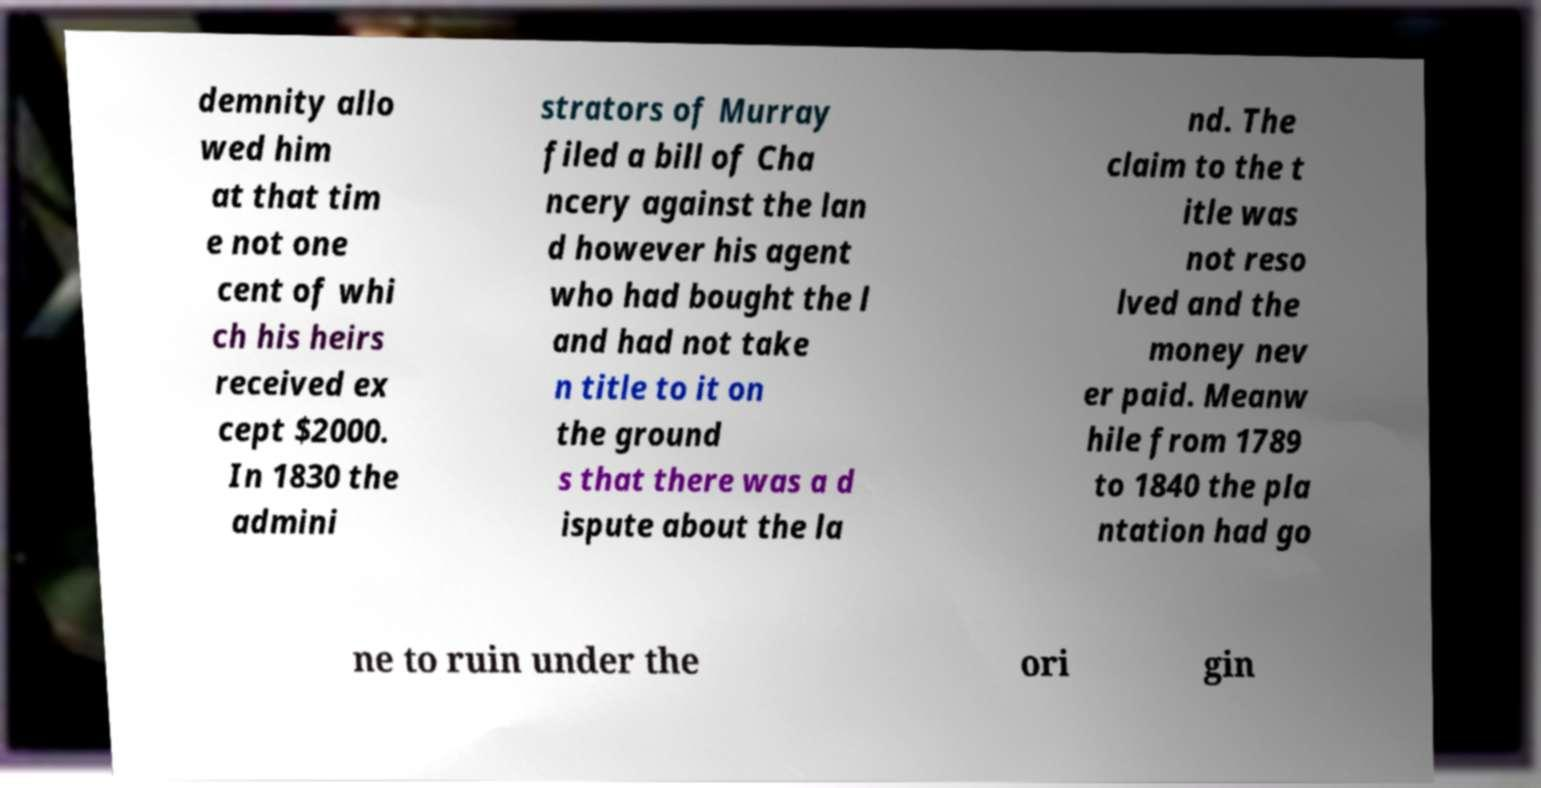I need the written content from this picture converted into text. Can you do that? demnity allo wed him at that tim e not one cent of whi ch his heirs received ex cept $2000. In 1830 the admini strators of Murray filed a bill of Cha ncery against the lan d however his agent who had bought the l and had not take n title to it on the ground s that there was a d ispute about the la nd. The claim to the t itle was not reso lved and the money nev er paid. Meanw hile from 1789 to 1840 the pla ntation had go ne to ruin under the ori gin 